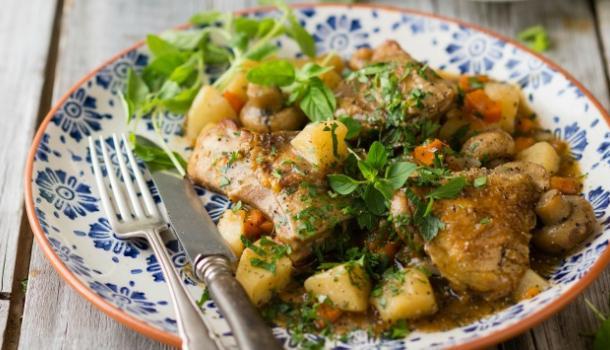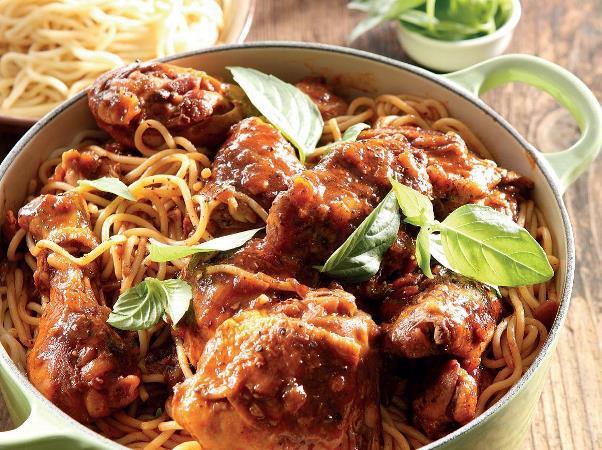The first image is the image on the left, the second image is the image on the right. Considering the images on both sides, is "One image shows a one-pot meal in a round container with two handles that is not sitting on a heat source." valid? Answer yes or no. Yes. The first image is the image on the left, the second image is the image on the right. For the images shown, is this caption "Food is on a plate in one of the images." true? Answer yes or no. Yes. 